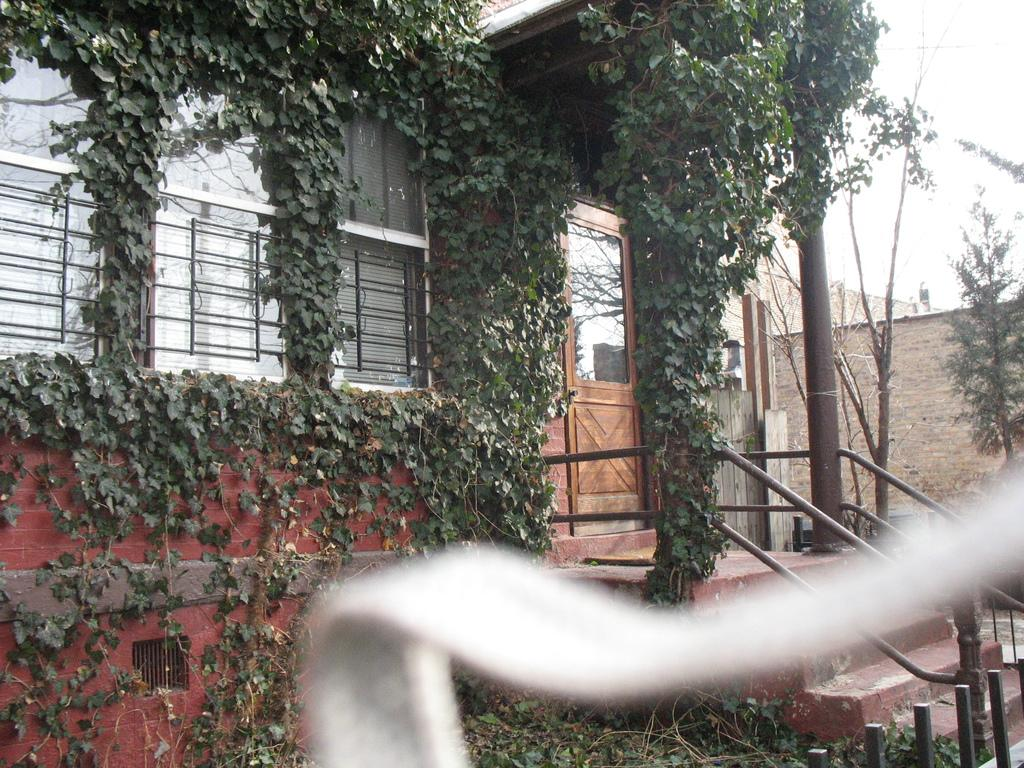What type of structure is present in the image? There is a building in the image. What other natural elements can be seen in the image? There are trees in the image. What can be seen in the distance in the image? The sky is visible in the background of the image. How many yaks are grazing in the field in the image? There are no yaks present in the image; it features a building, trees, and the sky. What type of fire can be seen in the image? There is no fire present in the image. 